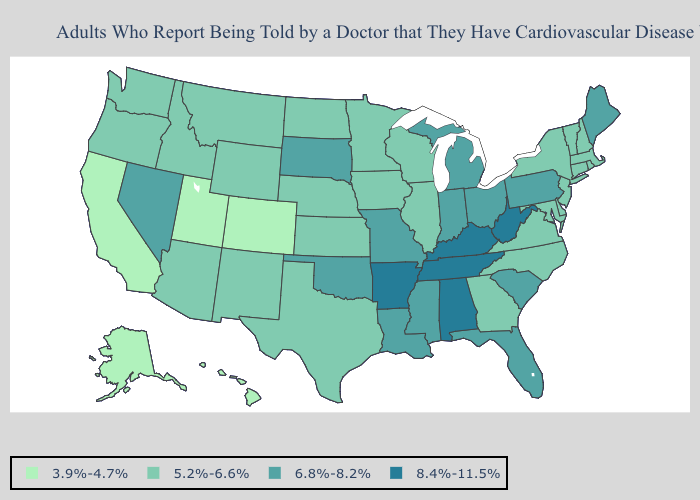Does the first symbol in the legend represent the smallest category?
Write a very short answer. Yes. What is the highest value in states that border Michigan?
Concise answer only. 6.8%-8.2%. Does Texas have the same value as Indiana?
Give a very brief answer. No. Name the states that have a value in the range 5.2%-6.6%?
Answer briefly. Arizona, Connecticut, Delaware, Georgia, Idaho, Illinois, Iowa, Kansas, Maryland, Massachusetts, Minnesota, Montana, Nebraska, New Hampshire, New Jersey, New Mexico, New York, North Carolina, North Dakota, Oregon, Rhode Island, Texas, Vermont, Virginia, Washington, Wisconsin, Wyoming. Name the states that have a value in the range 8.4%-11.5%?
Be succinct. Alabama, Arkansas, Kentucky, Tennessee, West Virginia. Does Idaho have the lowest value in the USA?
Short answer required. No. What is the value of Mississippi?
Give a very brief answer. 6.8%-8.2%. What is the highest value in the West ?
Answer briefly. 6.8%-8.2%. Does Hawaii have the lowest value in the West?
Quick response, please. Yes. What is the value of Minnesota?
Give a very brief answer. 5.2%-6.6%. Does Colorado have the lowest value in the West?
Be succinct. Yes. What is the value of Ohio?
Give a very brief answer. 6.8%-8.2%. What is the value of Virginia?
Quick response, please. 5.2%-6.6%. Does Washington have the lowest value in the West?
Answer briefly. No. What is the value of Massachusetts?
Concise answer only. 5.2%-6.6%. 